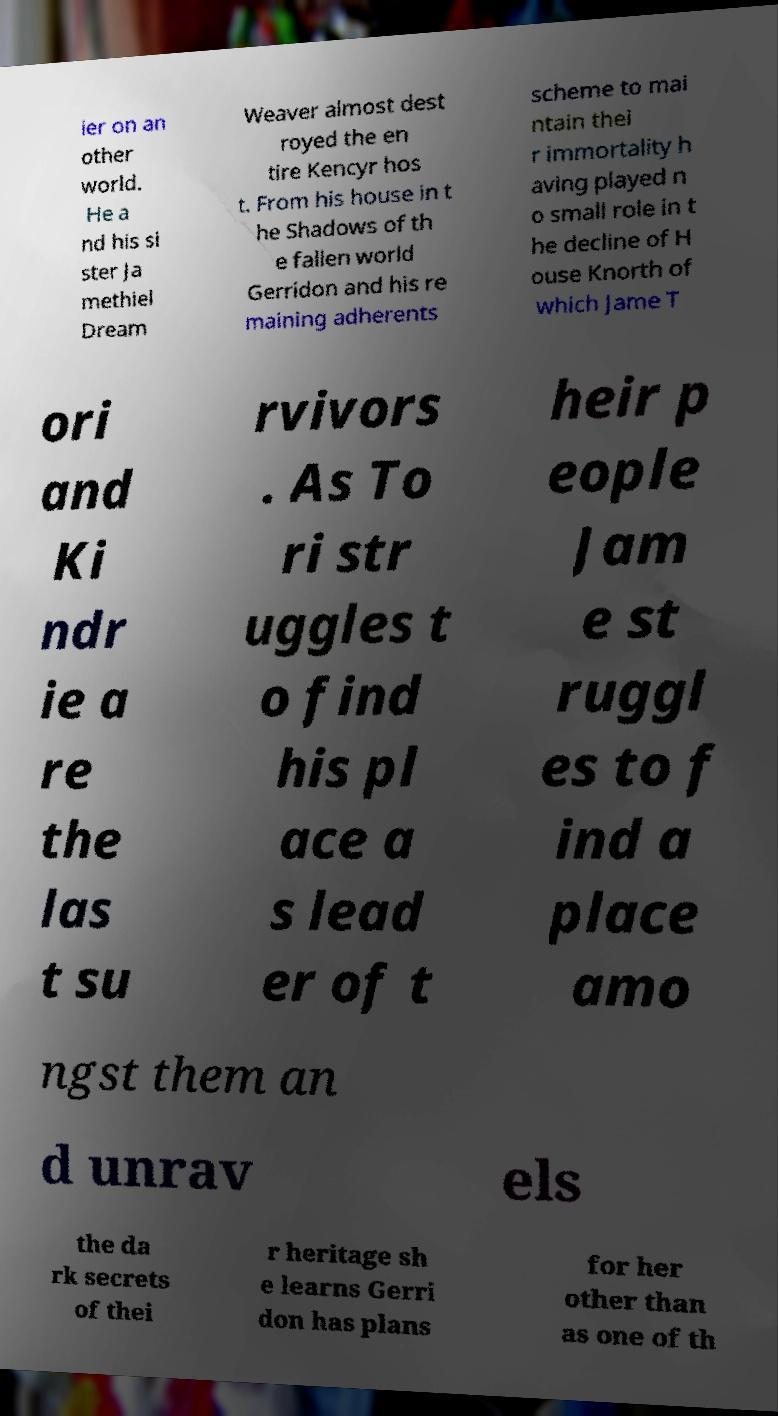Can you accurately transcribe the text from the provided image for me? ier on an other world. He a nd his si ster Ja methiel Dream Weaver almost dest royed the en tire Kencyr hos t. From his house in t he Shadows of th e fallen world Gerridon and his re maining adherents scheme to mai ntain thei r immortality h aving played n o small role in t he decline of H ouse Knorth of which Jame T ori and Ki ndr ie a re the las t su rvivors . As To ri str uggles t o find his pl ace a s lead er of t heir p eople Jam e st ruggl es to f ind a place amo ngst them an d unrav els the da rk secrets of thei r heritage sh e learns Gerri don has plans for her other than as one of th 